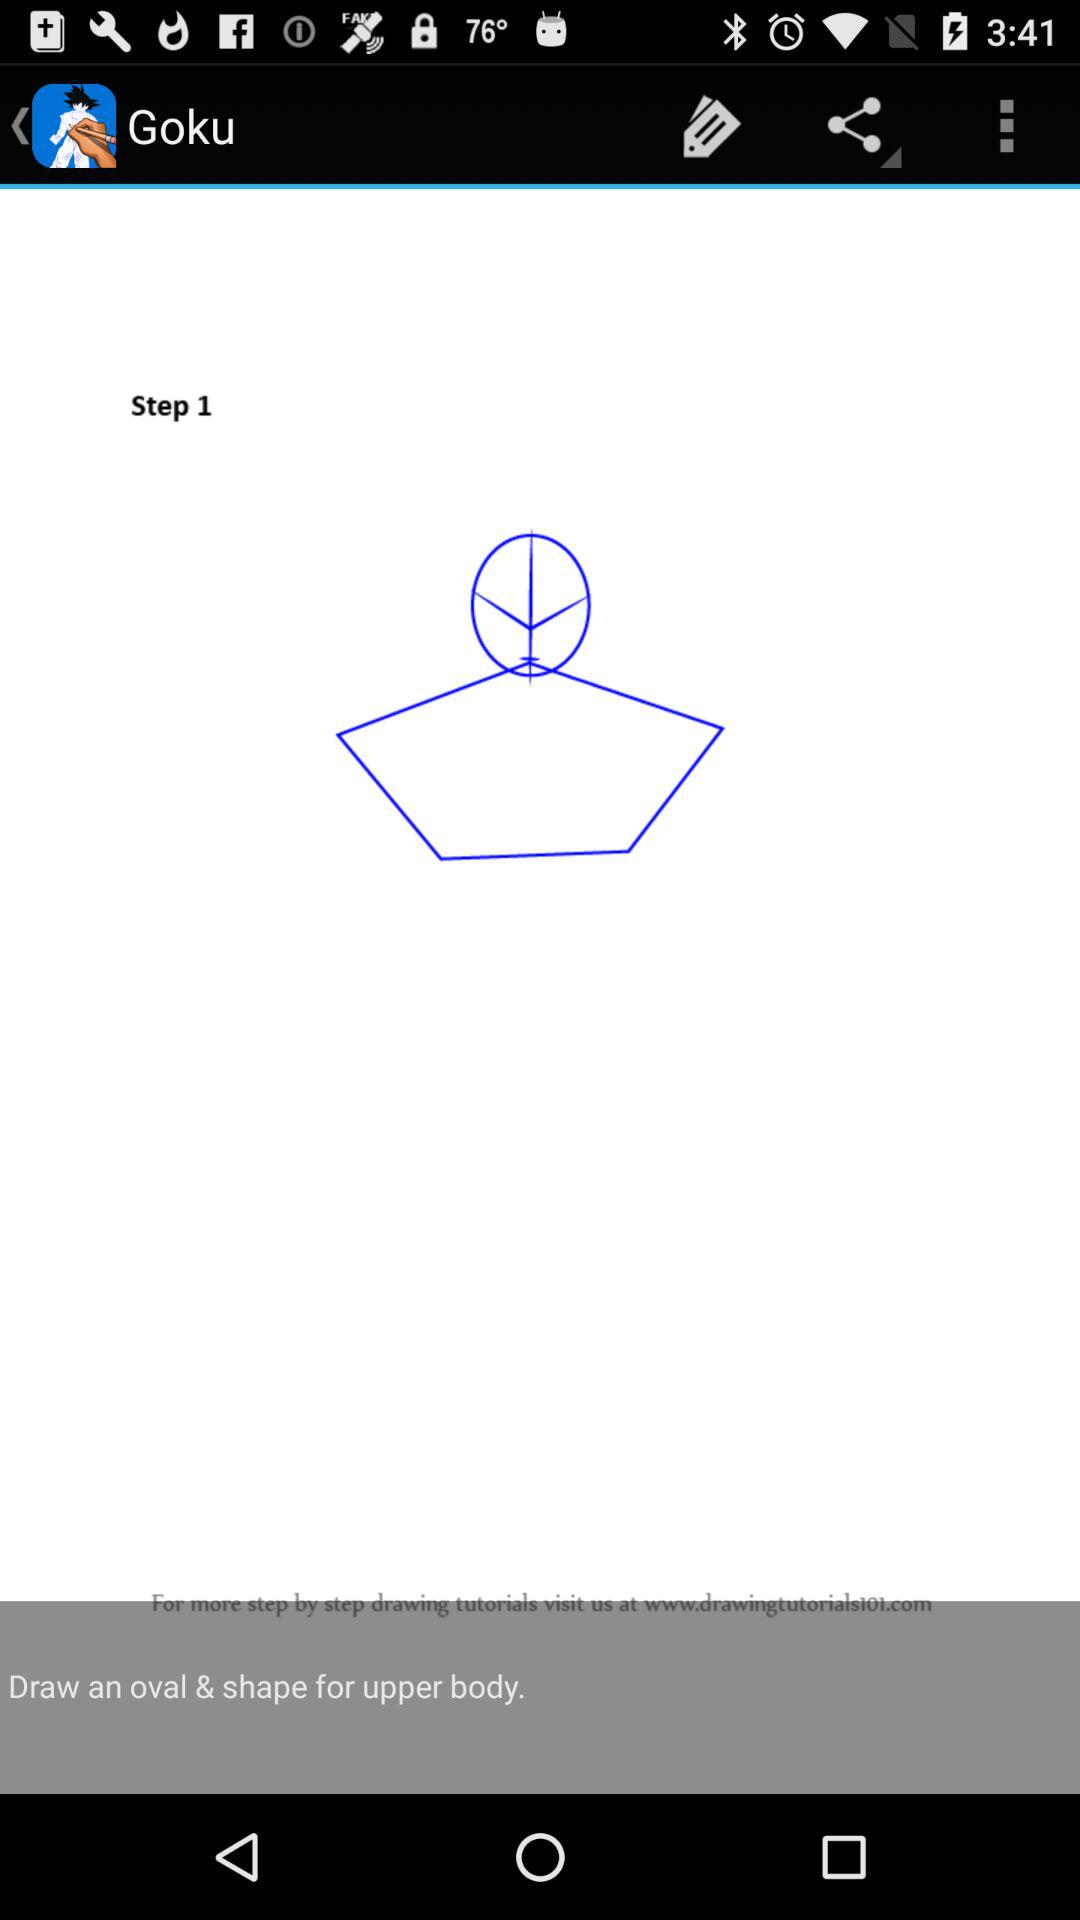How many steps are there in the drawing tutorial?
Answer the question using a single word or phrase. 1 